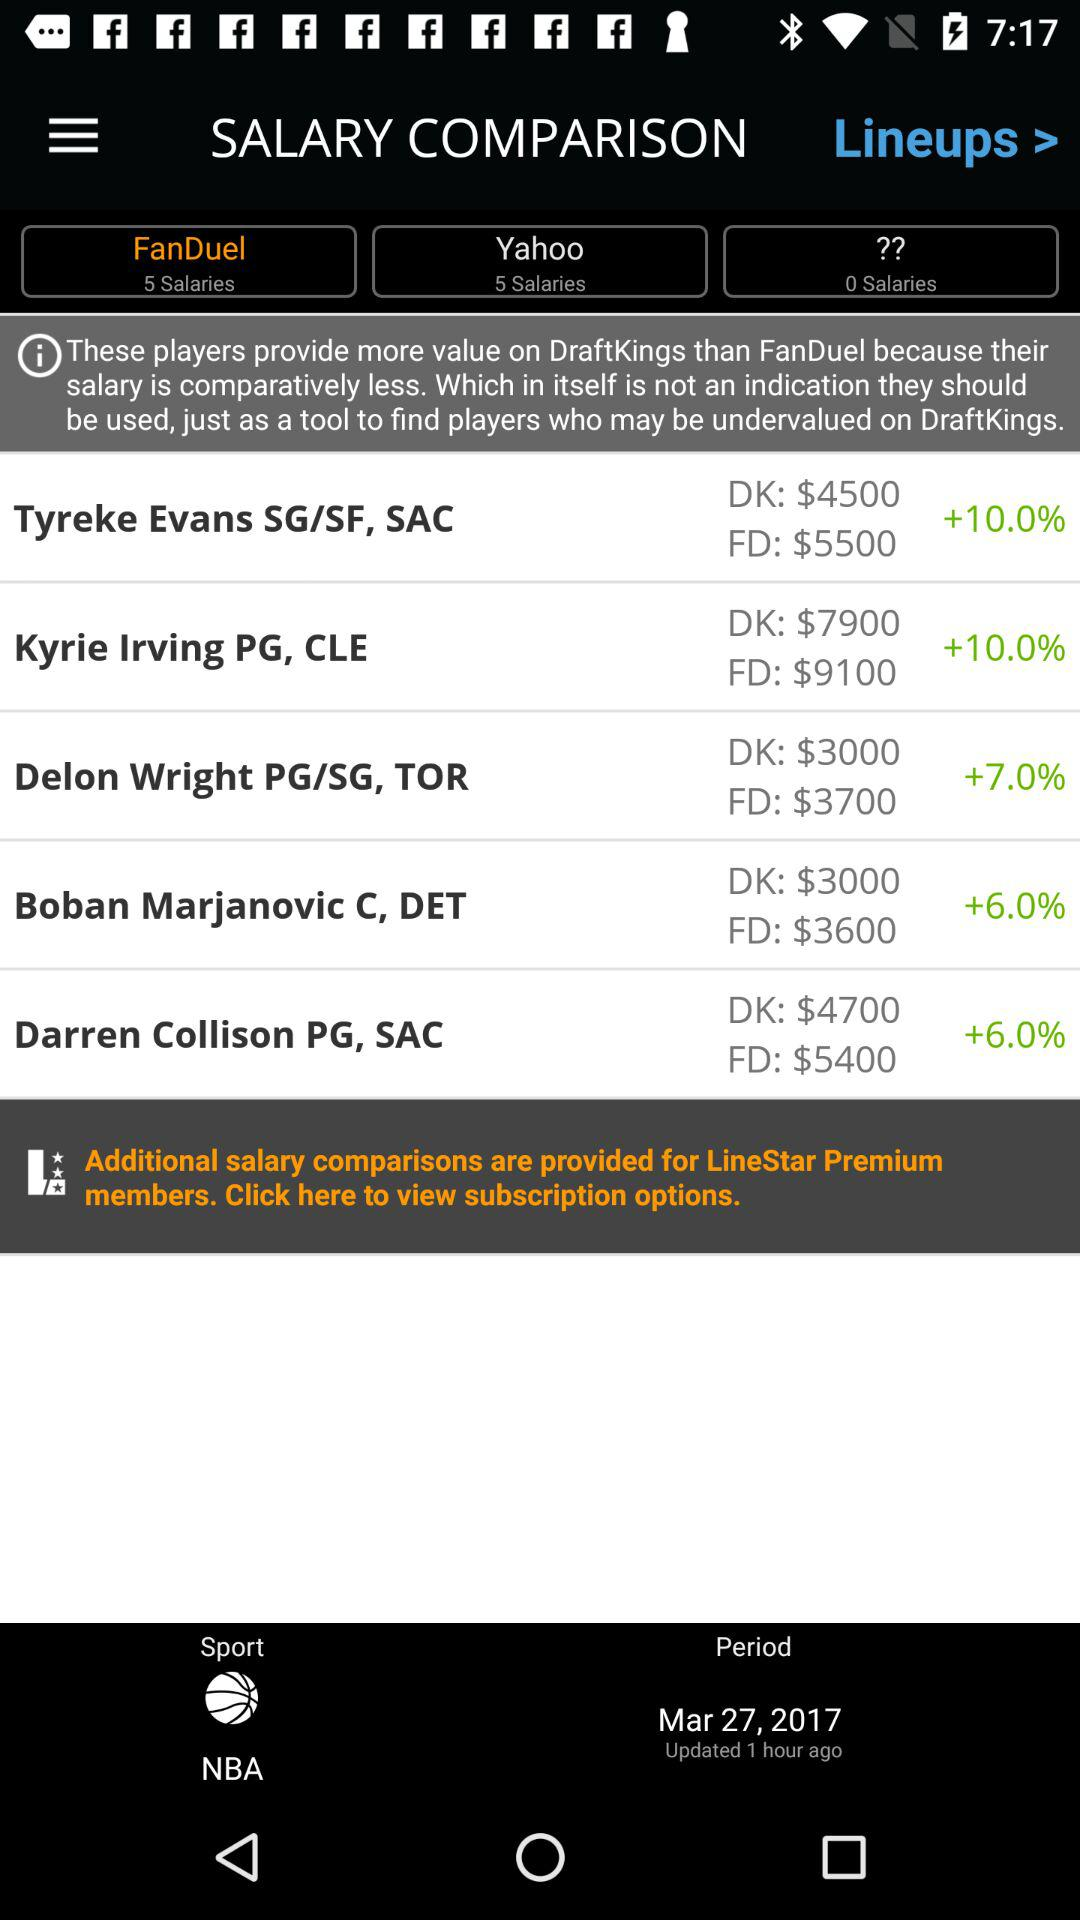What is the DK value of "Tyreke Evans SG/SF, SAC"? The DK value of "Tyreke Evans SG/SF, SAC" is $4500. 